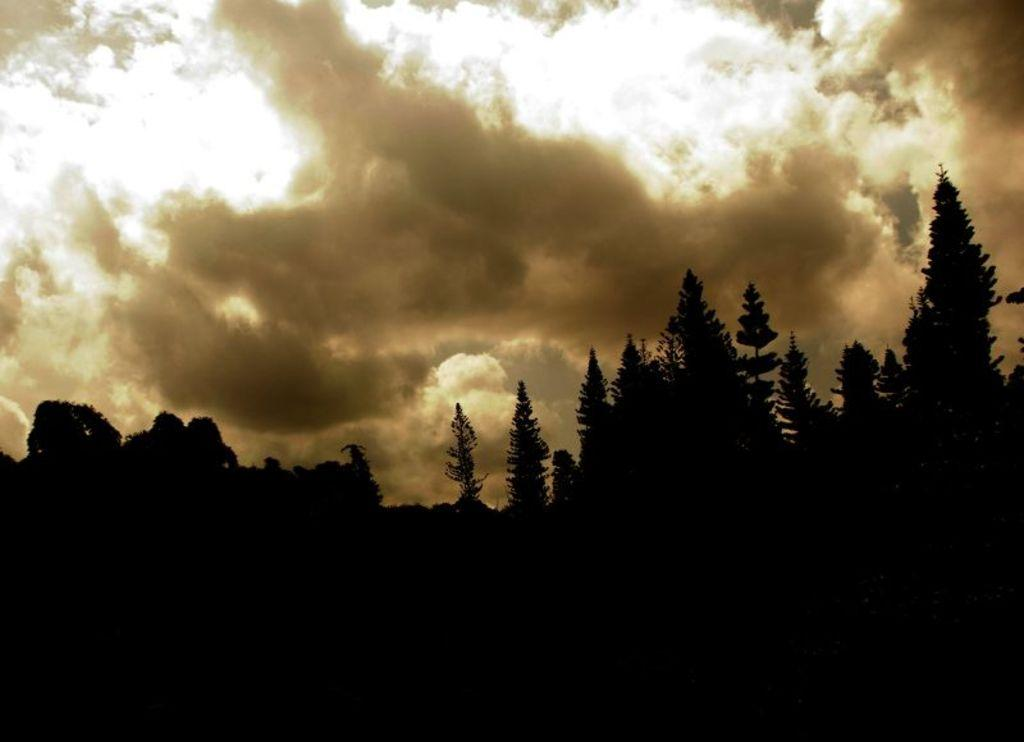What is located in the center of the image? There are trees in the center of the image. What can be seen in the background of the image? There is sky visible in the background of the image. How many chairs are placed around the cake in the image? There is no cake or chairs present in the image; it only features trees and sky. 